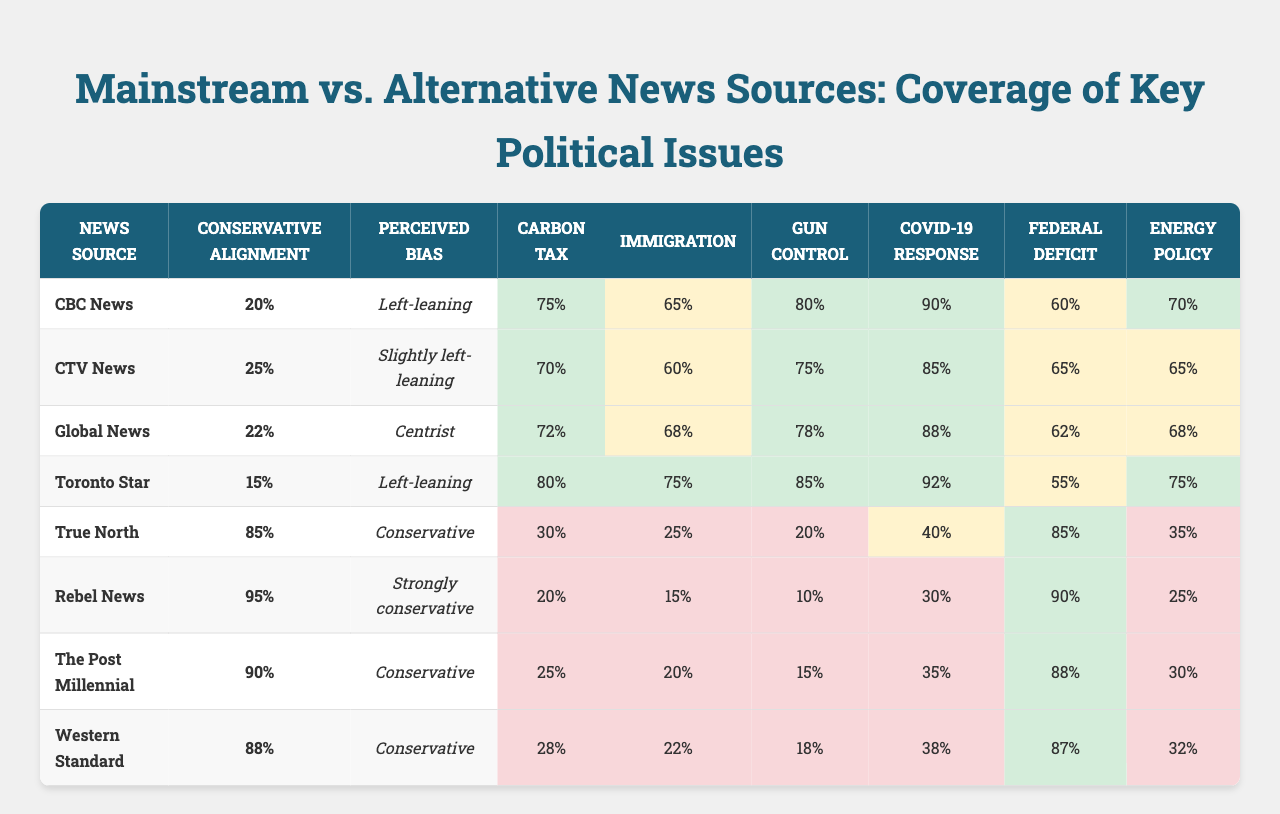What news source has the highest coverage for Gun Control? From the table, Toronto Star has the highest coverage for Gun Control at 85%.
Answer: Toronto Star Which news source shows a strong conservative alignment? Rebel News has the highest conservative alignment percentage of 95%.
Answer: Rebel News What is the average coverage percentage for the Federal Deficit across all news sources? To find the average, sum the percentages for Federal Deficit: (60 + 65 + 62 + 55 + 85 + 90 + 88 + 87) =  642. Then, divide by 8 news sources: 642 / 8 = 80.25%.
Answer: 80.25% Is there a correlation between conservative alignment and coverage of COVID-19 Response? Looking at the table, True North (85%) and Rebel News (30%) have the lowest percentages for COVID coverage and the highest conservative alignments, but CBC News (90%) contrasts with a lower conservative alignment (20%), indicating no strong correlation.
Answer: No Which news source has the lowest coverage for Energy Policy? The news source with the lowest coverage for Energy Policy is Rebel News at 25%.
Answer: Rebel News How many news sources have a perceived bias described as "Conservative" or higher? The table shows that True North, Rebel News, The Post Millennial, and Western Standard have perceived biases of Conservative or higher, totaling four news sources.
Answer: 4 What is the difference in coverage for Carbon Tax between CBC News and True North? CBC News covers Carbon Tax at 75%, while True North covers it at 30%. The difference is 75 - 30 = 45%.
Answer: 45% Which news source has the lowest perceived bias score? The source with the lowest perceived bias is Toronto Star, described as "Left-leaning".
Answer: Toronto Star What is the median coverage percentage for Immigration? Organizing the percentages for Immigration (65, 60, 68, 75, 25, 15, 20, 22) gives (15, 20, 22, 25, 60, 65, 68, 75). The median (average of 25 and 60) is (25 + 60) / 2 = 42.5%.
Answer: 42.5% Which issue has the highest average coverage across all mainstream media sources (CBC News, CTV News, Global News, and Toronto Star)? The average coverage for COVID-19 Response across those sources is (90 + 85 + 88 + 92) = 355, and dividing by 4 gives an average of 88.75%.
Answer: 88.75% 